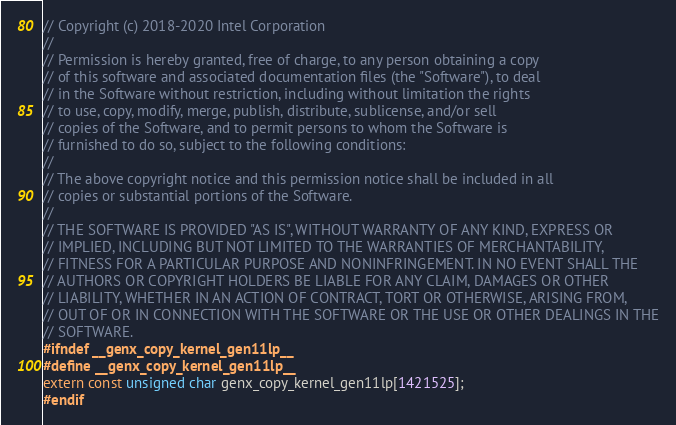<code> <loc_0><loc_0><loc_500><loc_500><_C_>// Copyright (c) 2018-2020 Intel Corporation
//
// Permission is hereby granted, free of charge, to any person obtaining a copy
// of this software and associated documentation files (the "Software"), to deal
// in the Software without restriction, including without limitation the rights
// to use, copy, modify, merge, publish, distribute, sublicense, and/or sell
// copies of the Software, and to permit persons to whom the Software is
// furnished to do so, subject to the following conditions:
//
// The above copyright notice and this permission notice shall be included in all
// copies or substantial portions of the Software.
//
// THE SOFTWARE IS PROVIDED "AS IS", WITHOUT WARRANTY OF ANY KIND, EXPRESS OR
// IMPLIED, INCLUDING BUT NOT LIMITED TO THE WARRANTIES OF MERCHANTABILITY,
// FITNESS FOR A PARTICULAR PURPOSE AND NONINFRINGEMENT. IN NO EVENT SHALL THE
// AUTHORS OR COPYRIGHT HOLDERS BE LIABLE FOR ANY CLAIM, DAMAGES OR OTHER
// LIABILITY, WHETHER IN AN ACTION OF CONTRACT, TORT OR OTHERWISE, ARISING FROM,
// OUT OF OR IN CONNECTION WITH THE SOFTWARE OR THE USE OR OTHER DEALINGS IN THE
// SOFTWARE.
#ifndef __genx_copy_kernel_gen11lp__
#define __genx_copy_kernel_gen11lp__
extern const unsigned char genx_copy_kernel_gen11lp[1421525];
#endif
</code> 